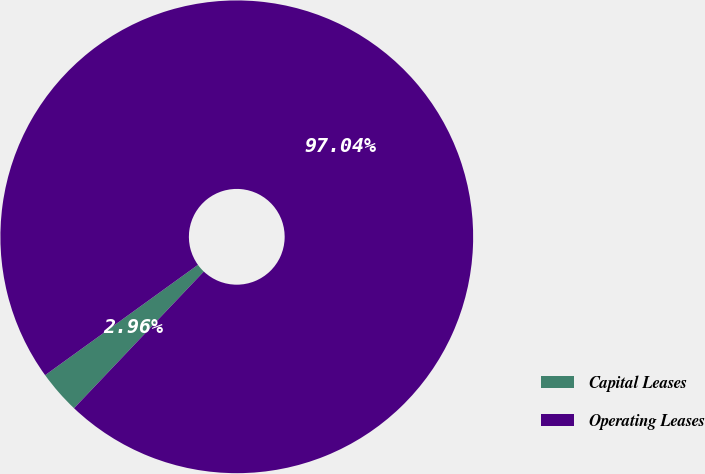<chart> <loc_0><loc_0><loc_500><loc_500><pie_chart><fcel>Capital Leases<fcel>Operating Leases<nl><fcel>2.96%<fcel>97.04%<nl></chart> 